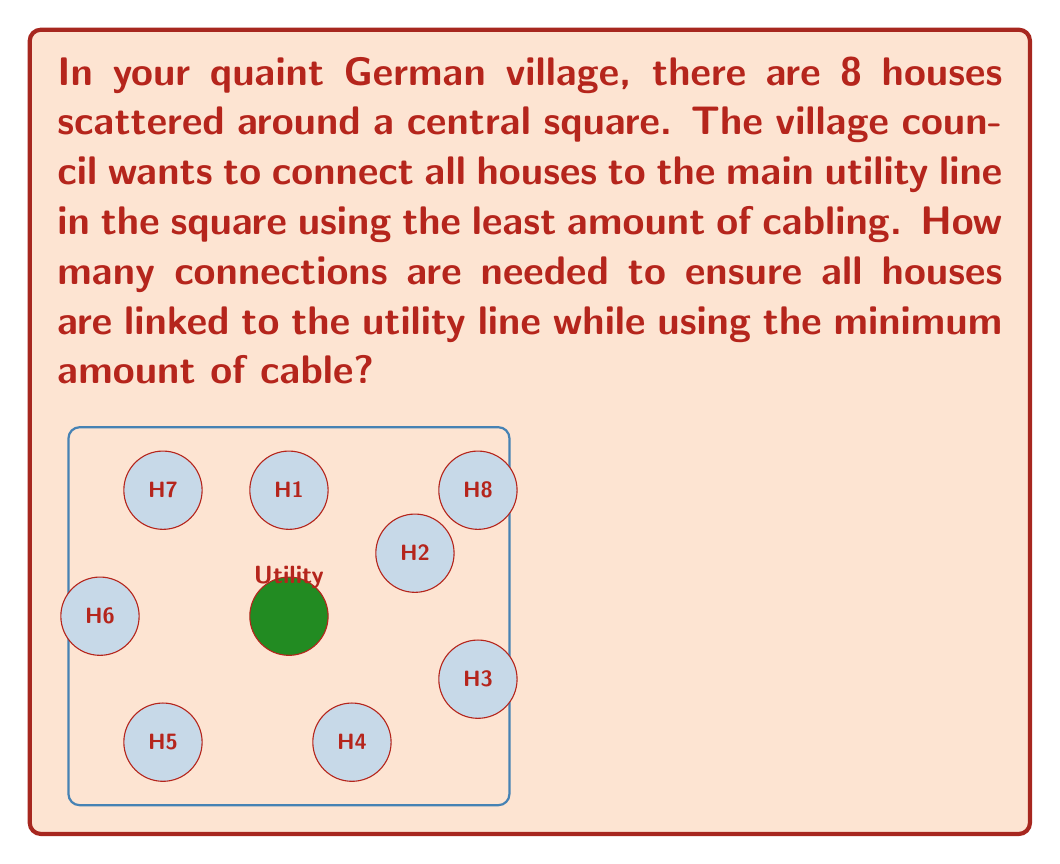Provide a solution to this math problem. To solve this problem, we need to use the concept of a minimum spanning tree in graph theory. Here's a step-by-step explanation:

1) In this scenario, each house and the central utility point can be considered as vertices in a graph.

2) The connections between houses and the utility point are the edges of the graph.

3) We want to find a tree (a connected graph without cycles) that spans all vertices (reaches all houses) and has the minimum number of edges.

4) In a tree, the number of edges is always one less than the number of vertices.

5) In our case:
   - Number of houses: 8
   - Central utility point: 1
   - Total number of vertices: $8 + 1 = 9$

6) Therefore, the minimum number of connections (edges) needed is:

   $$\text{Number of connections} = \text{Number of vertices} - 1 = 9 - 1 = 8$$

This solution ensures that all houses are connected to the utility while using the minimum amount of cabling.
Answer: 8 connections 